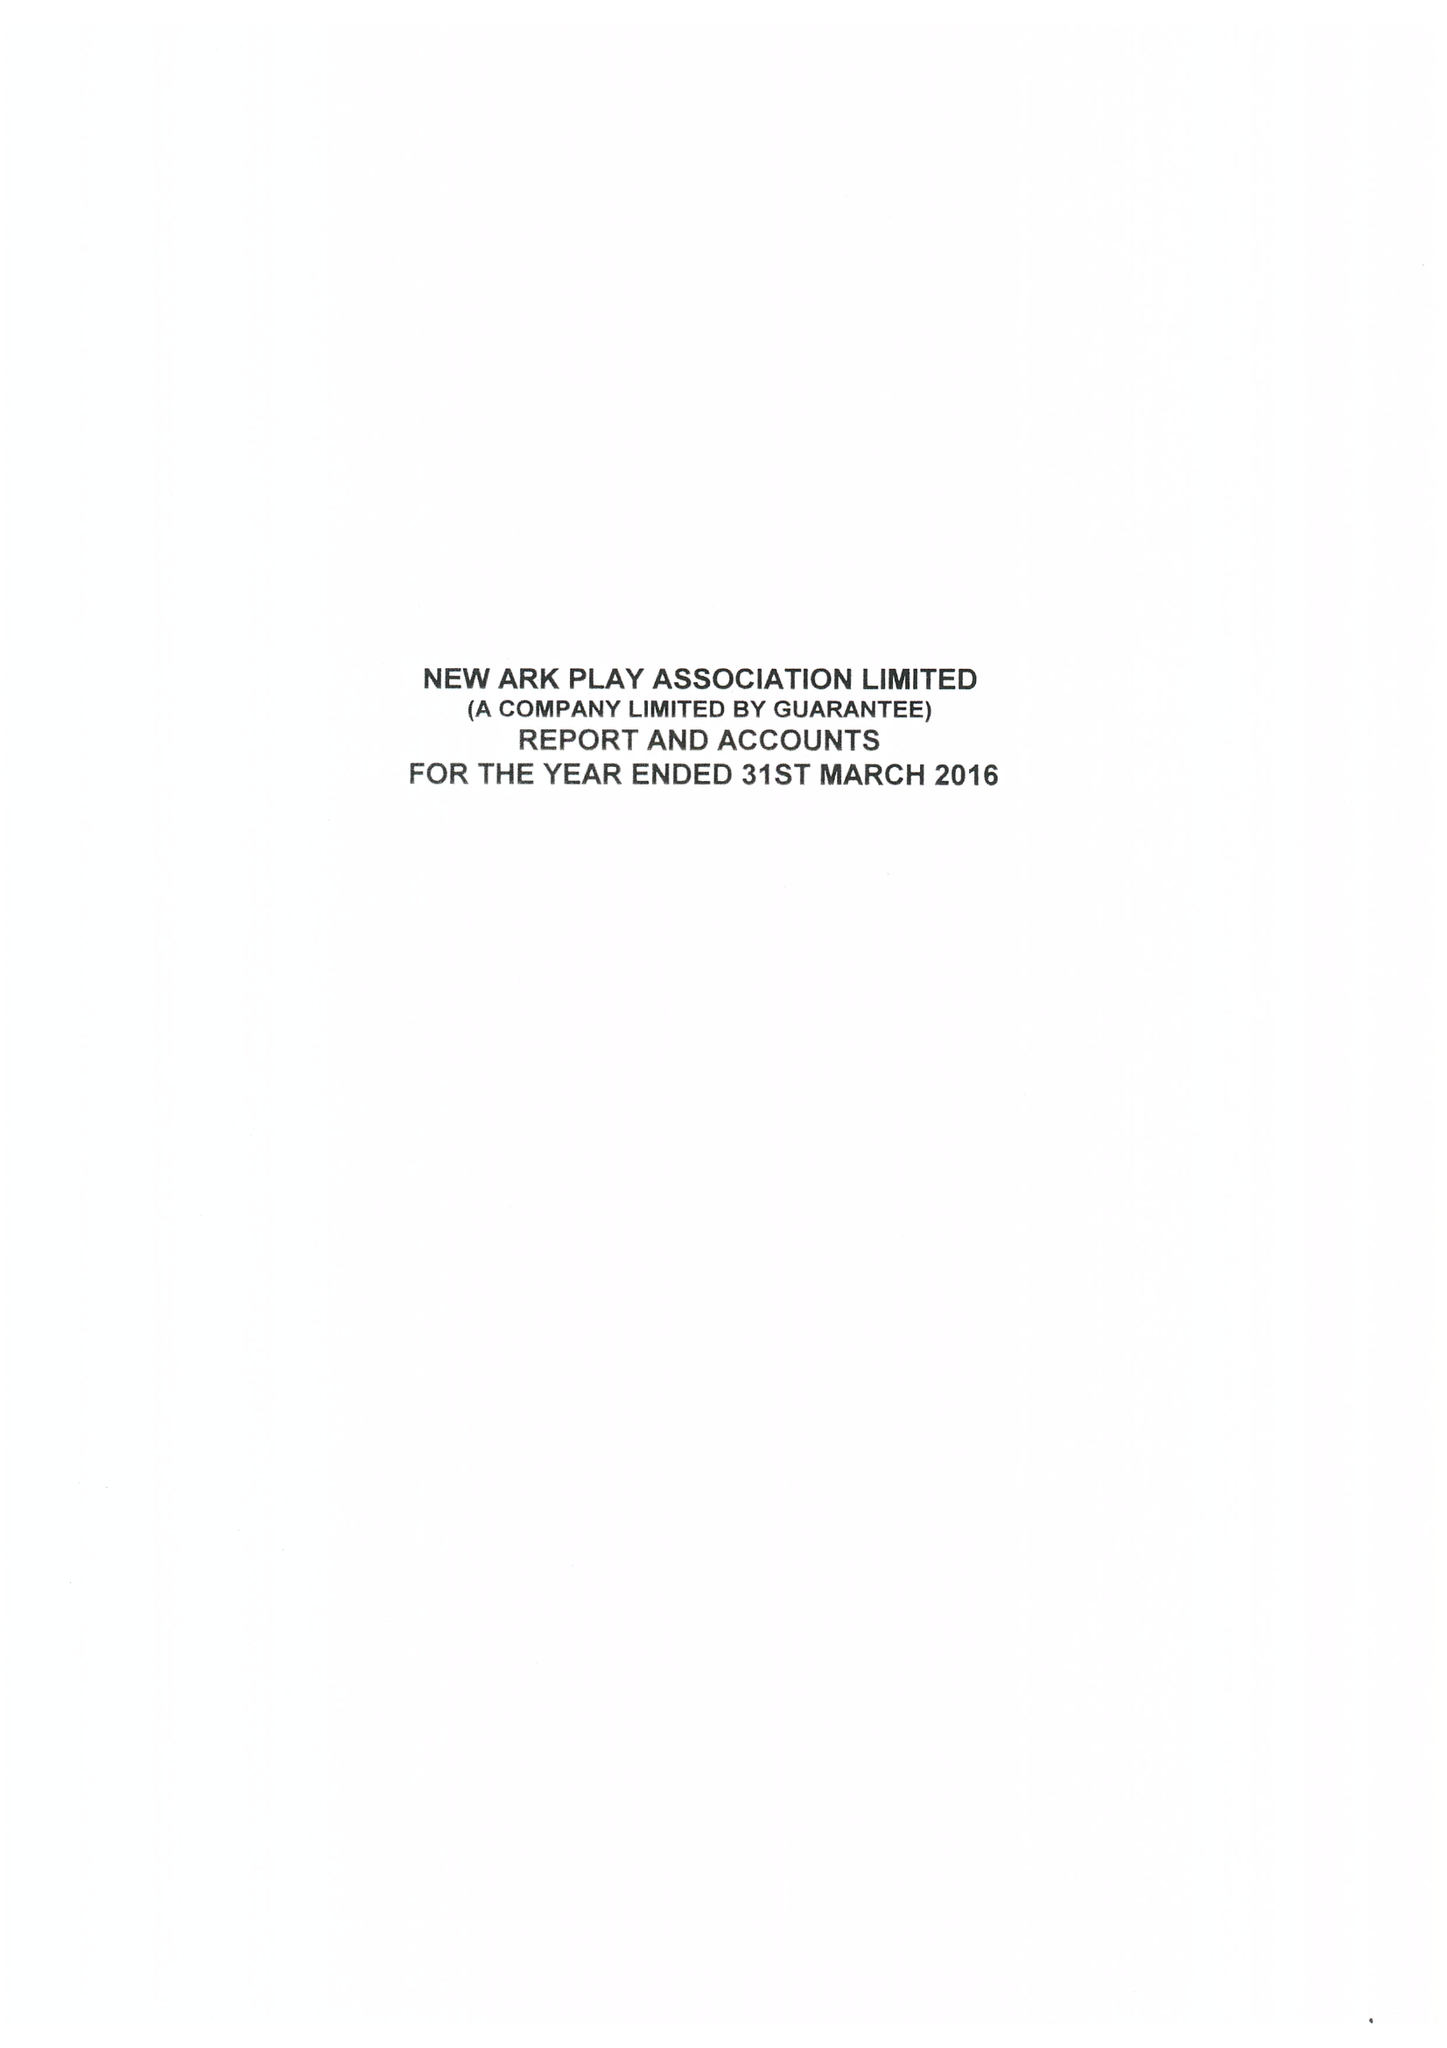What is the value for the address__street_line?
Answer the question using a single word or phrase. 23 HAWTHORN ROAD 